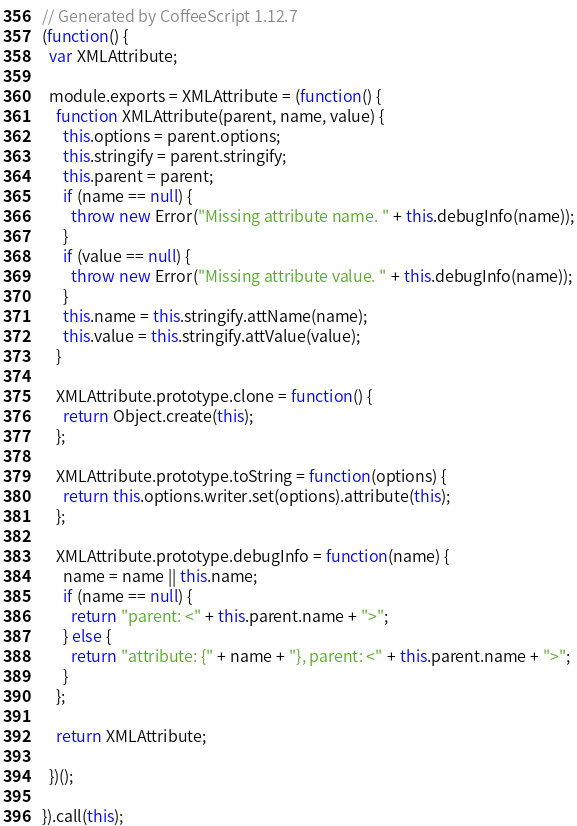<code> <loc_0><loc_0><loc_500><loc_500><_JavaScript_>// Generated by CoffeeScript 1.12.7
(function() {
  var XMLAttribute;

  module.exports = XMLAttribute = (function() {
    function XMLAttribute(parent, name, value) {
      this.options = parent.options;
      this.stringify = parent.stringify;
      this.parent = parent;
      if (name == null) {
        throw new Error("Missing attribute name. " + this.debugInfo(name));
      }
      if (value == null) {
        throw new Error("Missing attribute value. " + this.debugInfo(name));
      }
      this.name = this.stringify.attName(name);
      this.value = this.stringify.attValue(value);
    }

    XMLAttribute.prototype.clone = function() {
      return Object.create(this);
    };

    XMLAttribute.prototype.toString = function(options) {
      return this.options.writer.set(options).attribute(this);
    };

    XMLAttribute.prototype.debugInfo = function(name) {
      name = name || this.name;
      if (name == null) {
        return "parent: <" + this.parent.name + ">";
      } else {
        return "attribute: {" + name + "}, parent: <" + this.parent.name + ">";
      }
    };

    return XMLAttribute;

  })();

}).call(this);
</code> 